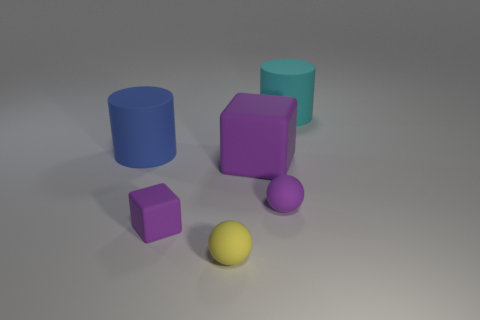Is the purple cube larger or smaller than the purple prism? The purple prism is larger than the purple cube. What could these objects represent metaphorically or in an abstract sense? Metaphorically, the objects could represent differing ideas or individuals, each with their own unique characteristics and standing out in their color and shape, signifying diversity and individuality within a group. 